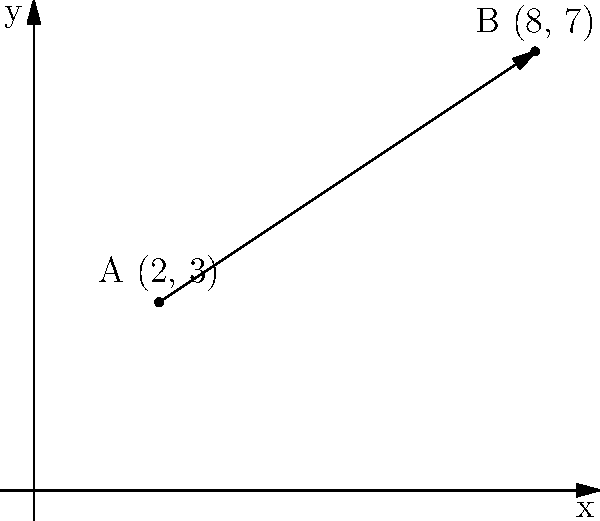As the grumpy sysadmin, you're tasked with calculating the distance between two backup storage locations. Location A is at coordinates (2, 3) and Location B is at (8, 7) on your data center floor plan. What is the shortest distance between these two points? Round your answer to two decimal places. To calculate the shortest distance between two points on a 2D plane, we use the distance formula derived from the Pythagorean theorem:

$$ d = \sqrt{(x_2 - x_1)^2 + (y_2 - y_1)^2} $$

Where $(x_1, y_1)$ are the coordinates of the first point and $(x_2, y_2)$ are the coordinates of the second point.

Given:
- Point A: (2, 3)
- Point B: (8, 7)

Let's plug these into our formula:

$$ d = \sqrt{(8 - 2)^2 + (7 - 3)^2} $$

Simplify:
$$ d = \sqrt{6^2 + 4^2} $$
$$ d = \sqrt{36 + 16} $$
$$ d = \sqrt{52} $$

Calculate the square root:
$$ d \approx 7.211102551 $$

Rounding to two decimal places:
$$ d \approx 7.21 $$

This distance is measured in the same units as your coordinate system, which in this case would likely be meters or feet, depending on your data center's standard unit of measurement.
Answer: 7.21 units 